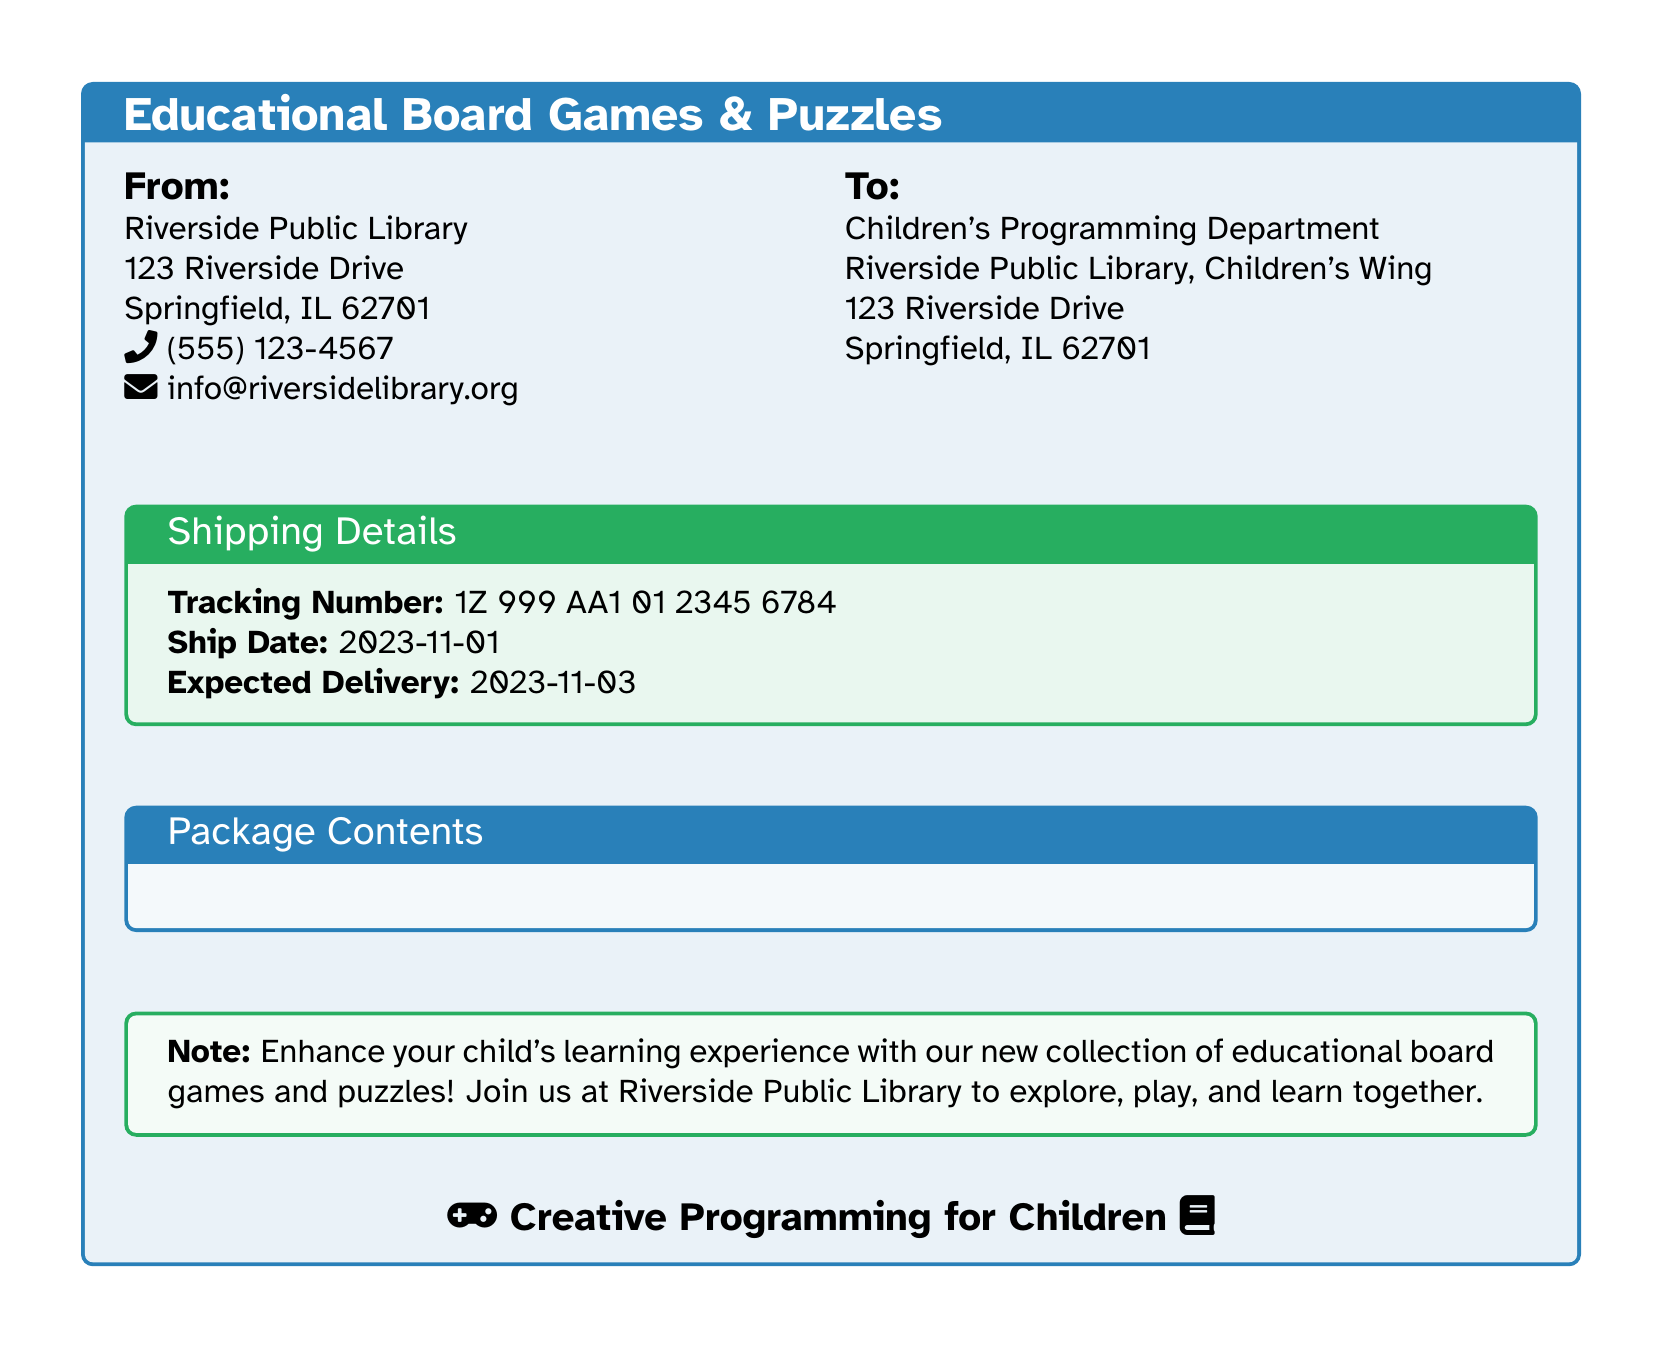What is the shipping date? The shipping date is specified in the shipping details section of the document as the date the package was sent.
Answer: 2023-11-01 What is the tracking number? The tracking number is provided in the shipping details section as a unique identifier for the shipment.
Answer: 1Z 999 AA1 01 2345 6784 What is the expected delivery date? The expected delivery date is mentioned in the shipping details section and indicates when the package should arrive.
Answer: 2023-11-03 How many games are listed in the package contents? The document lists the number of games in the package contents section for clarity.
Answer: 4 What age is recommended for the game "Pandemic"? The document includes age recommendations for each game, providing essential information for parents.
Answer: 10+ What is the publisher of "Ticket to Ride"? The document specifies the publisher for each game, which is important for identifying the source of the games.
Answer: Days of Wonder What type of programming does the label promote? The label features a section that encourages engaging programming for children, emphasizing its educational value.
Answer: Creative Programming Which game includes 50 state cards? The document outlines the contents of each game, allowing for easy identification of specific components in the games.
Answer: The Scrambled States of America Game What is the color of the shipping details box? The color scheme of each section is represented in the document, which gives it a distinctive visual appeal.
Answer: Green 